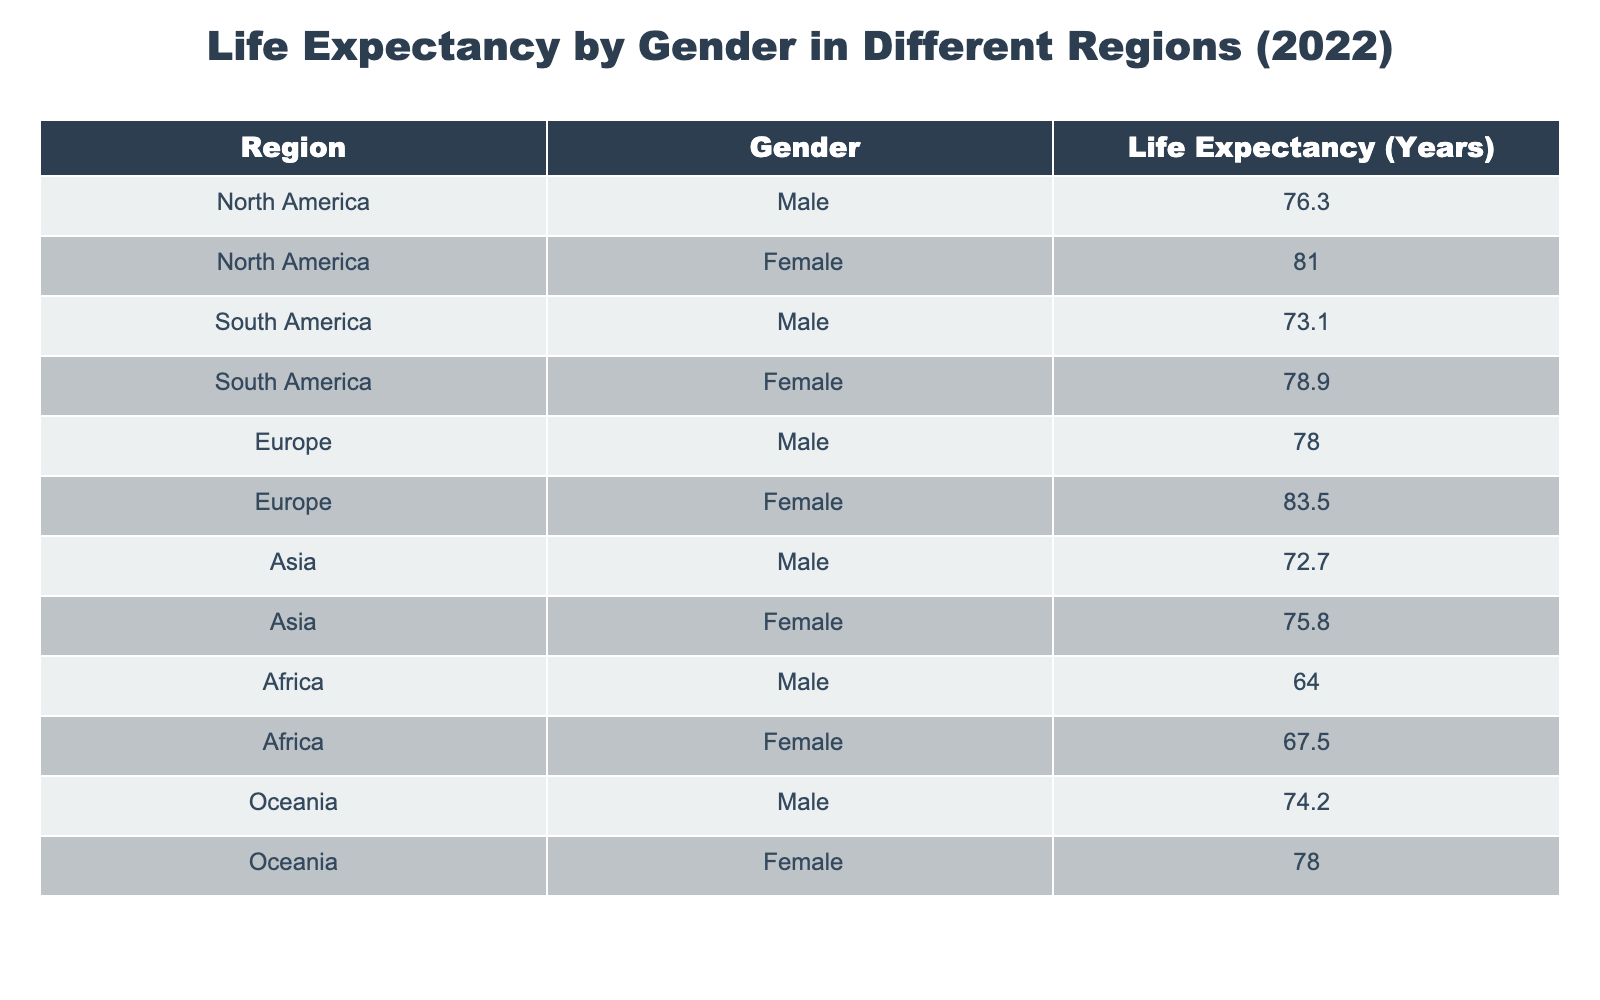What is the life expectancy for females in Europe? In the table, we find the entry for Europe under the Female category, which shows a life expectancy of 83.5 years.
Answer: 83.5 Which region has the lowest life expectancy for males? Looking through the table, Africa has the lowest life expectancy for males at 64.0 years.
Answer: 64.0 What is the average life expectancy for females in North America and South America? For North America, the female life expectancy is 81.0 years, and for South America, it is 78.9 years. We add them together: 81.0 + 78.9 = 159.9 and then divide by 2 for the average: 159.9 / 2 = 79.95.
Answer: 79.95 Is the life expectancy for males in Oceania higher than in Africa? The life expectancy for males in Oceania is 74.2 years, and in Africa, it is 64.0 years. Since 74.2 is greater than 64.0, the answer is yes.
Answer: Yes Which gender has a higher life expectancy in Asia, and what is the difference? In Asia, the male life expectancy is 72.7 years, while the female life expectancy is 75.8 years. The difference can be calculated by subtracting the male life expectancy from the female: 75.8 - 72.7 = 3.1 years.
Answer: Female, difference 3.1 What is the total life expectancy of all males in the given regions? Summing the life expectancy of males: 76.3 (North America) + 73.1 (South America) + 78.0 (Europe) + 72.7 (Asia) + 64.0 (Africa) + 74.2 (Oceania) results in 438.3.
Answer: 438.3 Is the life expectancy for females in North America greater than that in Oceania? The female life expectancy in North America is 81.0 years, while in Oceania it is 78.0 years. Since 81.0 is greater than 78.0, the answer is yes.
Answer: Yes What is the median life expectancy for males across all regions? The male life expectancies are: 76.3, 73.1, 78.0, 72.7, 64.0, and 74.2. Sorting these values gives: 64.0, 72.7, 73.1, 74.2, 76.3, 78.0. The median, which is the average of the two middle numbers (73.1 and 74.2), is (73.1 + 74.2) / 2 = 73.65.
Answer: 73.65 How much longer do females live compared to males in South America? In South America, females have a life expectancy of 78.9 years, and males have 73.1 years. The difference is calculated by subtracting the male's life expectancy from that of the female: 78.9 - 73.1 = 5.8 years.
Answer: 5.8 